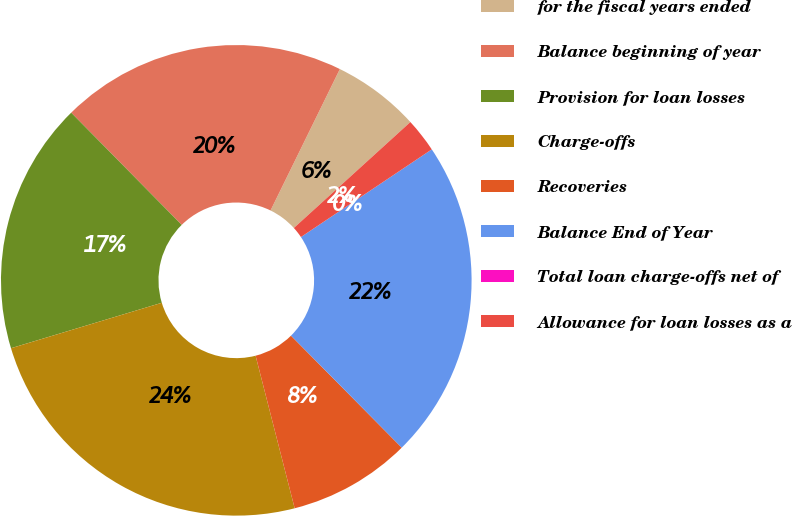Convert chart. <chart><loc_0><loc_0><loc_500><loc_500><pie_chart><fcel>for the fiscal years ended<fcel>Balance beginning of year<fcel>Provision for loan losses<fcel>Charge-offs<fcel>Recoveries<fcel>Balance End of Year<fcel>Total loan charge-offs net of<fcel>Allowance for loan losses as a<nl><fcel>6.0%<fcel>19.63%<fcel>17.28%<fcel>24.33%<fcel>8.42%<fcel>21.98%<fcel>0.0%<fcel>2.35%<nl></chart> 